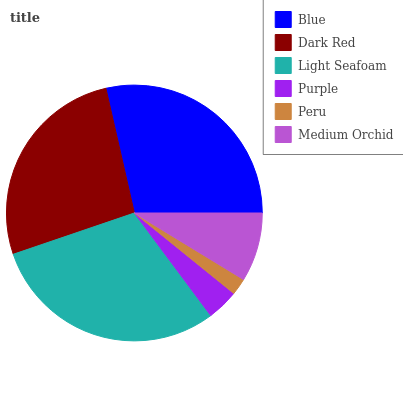Is Peru the minimum?
Answer yes or no. Yes. Is Light Seafoam the maximum?
Answer yes or no. Yes. Is Dark Red the minimum?
Answer yes or no. No. Is Dark Red the maximum?
Answer yes or no. No. Is Blue greater than Dark Red?
Answer yes or no. Yes. Is Dark Red less than Blue?
Answer yes or no. Yes. Is Dark Red greater than Blue?
Answer yes or no. No. Is Blue less than Dark Red?
Answer yes or no. No. Is Dark Red the high median?
Answer yes or no. Yes. Is Medium Orchid the low median?
Answer yes or no. Yes. Is Blue the high median?
Answer yes or no. No. Is Purple the low median?
Answer yes or no. No. 